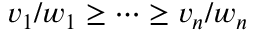<formula> <loc_0><loc_0><loc_500><loc_500>v _ { 1 } / w _ { 1 } \geq \cdots \geq v _ { n } / w _ { n }</formula> 